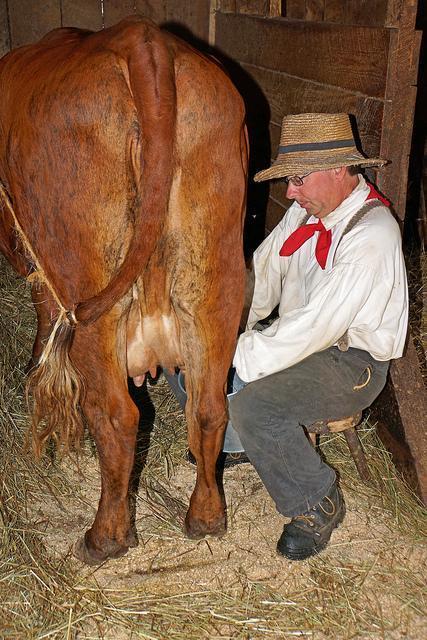How many suitcases are there?
Give a very brief answer. 0. 